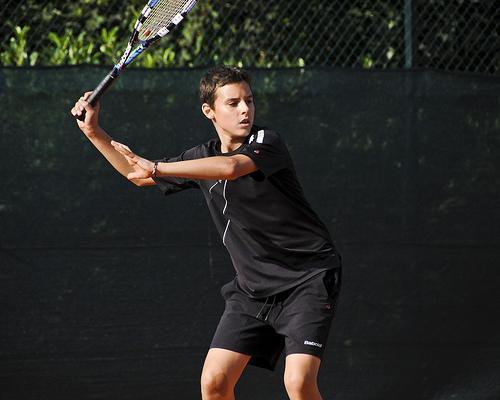How many people are in the picture?
Give a very brief answer. 1. 